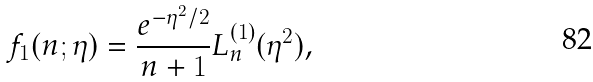Convert formula to latex. <formula><loc_0><loc_0><loc_500><loc_500>f _ { 1 } ( n ; \eta ) = \frac { e ^ { - \eta ^ { 2 } / 2 } } { n + 1 } L _ { n } ^ { ( 1 ) } ( \eta ^ { 2 } ) ,</formula> 